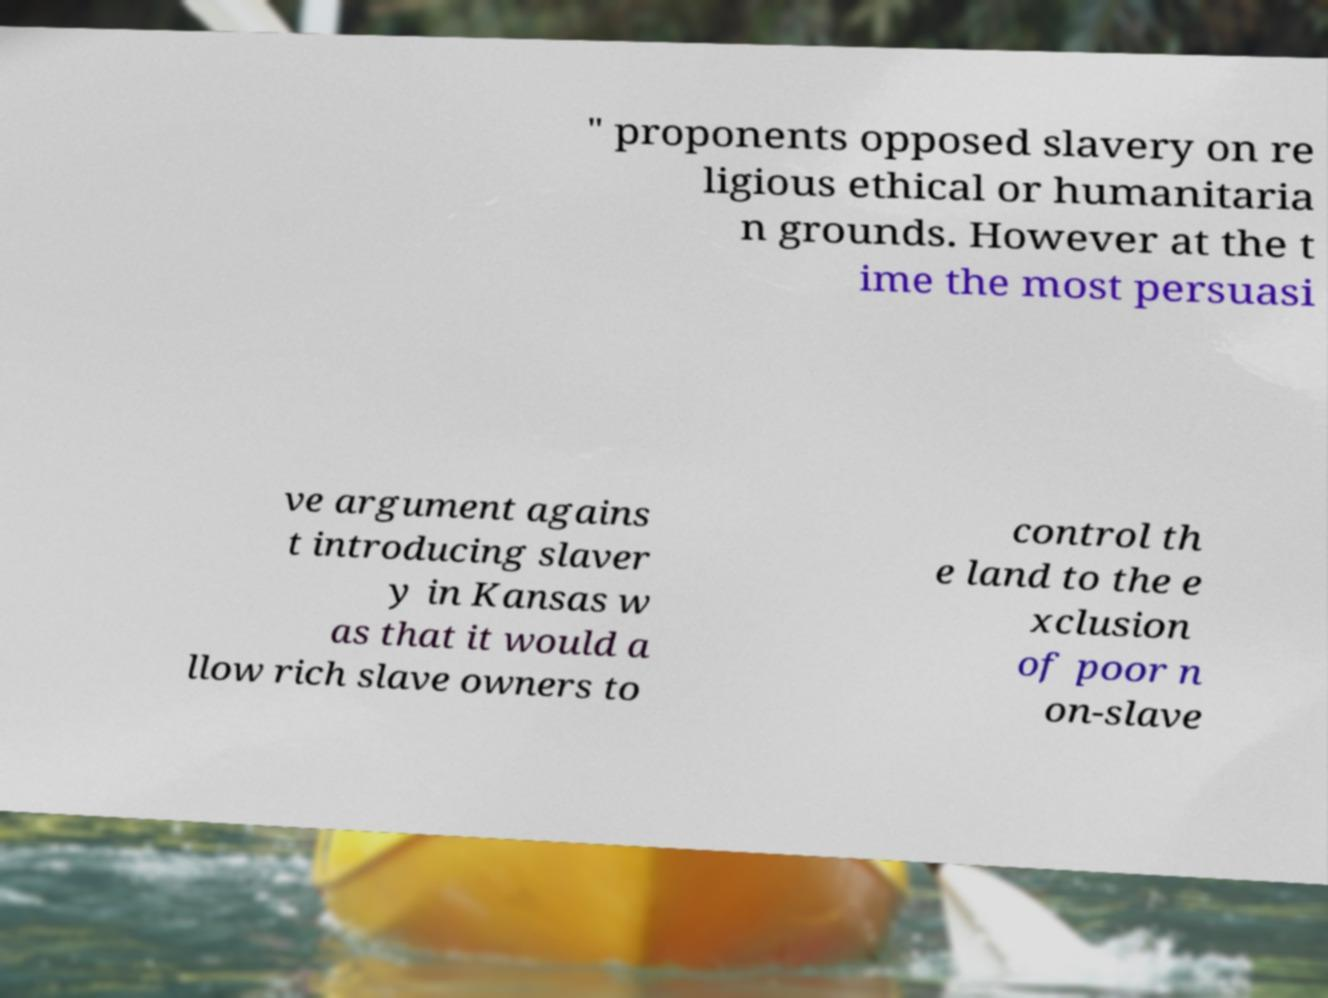For documentation purposes, I need the text within this image transcribed. Could you provide that? " proponents opposed slavery on re ligious ethical or humanitaria n grounds. However at the t ime the most persuasi ve argument agains t introducing slaver y in Kansas w as that it would a llow rich slave owners to control th e land to the e xclusion of poor n on-slave 